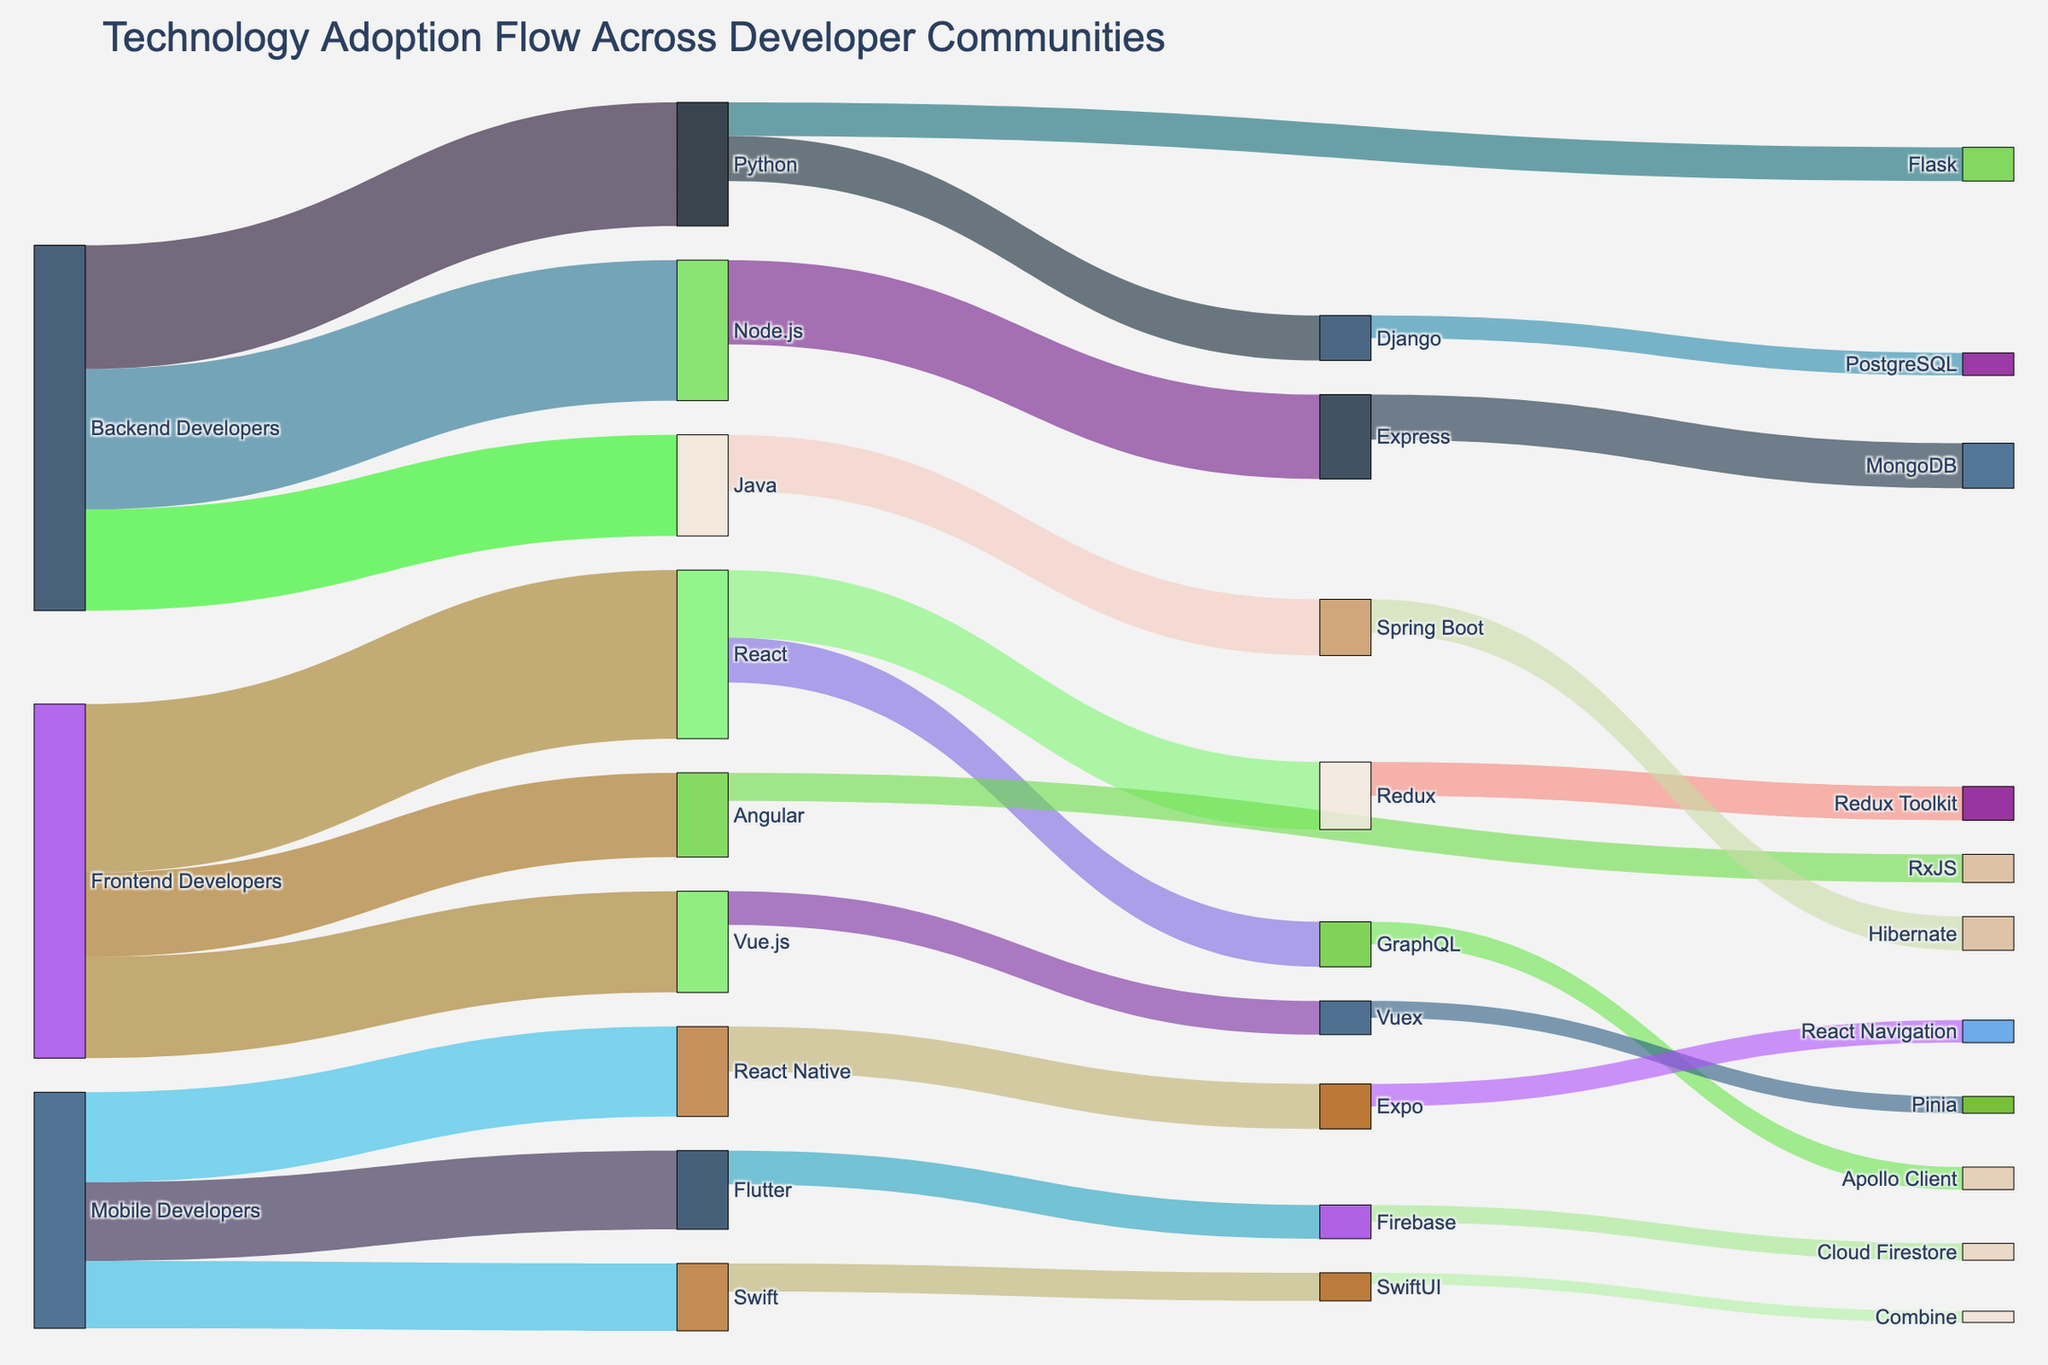What's the total number of Frontend Developers represented in the figure? To find the total number of Frontend Developers, sum the values connected from 'Frontend Developers' node: React (3000) + Vue.js (1800) + Angular (1500)
Answer: 6300 Which technology has the highest adoption among Backend Developers? To determine this, compare the values from the 'Backend Developers' node: Node.js (2500), Python (2200), Java (1800). Node.js has the highest value.
Answer: Node.js What's the overall adoption of mobile development technologies? Sum the values connected from the 'Mobile Developers' node: React Native (1600) + Flutter (1400) + Swift (1200)
Answer: 4200 Which framework under React has the higher adoption, GraphQL or Redux? Compare the values from the 'React' node: GraphQL (800) and Redux (1200). Redux has the higher value.
Answer: Redux How many developers use Python for backend development and also adopt Django? Look for the flow from 'Backend Developers' to 'Python' (2200) and then 'Python' to 'Django' (800). The correct flow is defined by the smaller value at the second step.
Answer: 800 What's the difference in adoption between Vue.js and Angular among Frontend Developers? Compare the values, with Vue.js at 1800 and Angular at 1500. The difference is 1800 - 1500.
Answer: 300 Which technology under Node.js has the highest adoption, Express or MongoDB? Compare the values from the 'Node.js' node: Express (1500) and MongoDB (800). Express has the highest value.
Answer: Express Are there more developers using SwiftUI or Combine under Swift? Compare the values connected from 'Swift' node: SwiftUI (500) and Combine (200). SwiftUI has more developers.
Answer: SwiftUI What's the total number of flows in the diagram? Count each unique source to target connection. There are 25 unique flows as listed in the data.
Answer: 25 Which node directly connects to the most number of other nodes? Check the node with the most outgoing or incoming connections. 'Frontend Developers' connects to 3 nodes (React, Vue.js, Angular).
Answer: Frontend Developers 